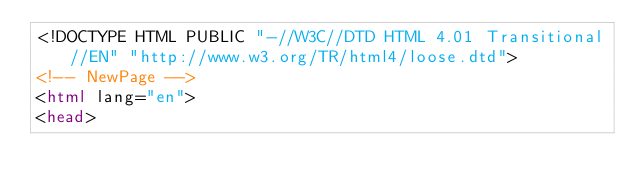<code> <loc_0><loc_0><loc_500><loc_500><_HTML_><!DOCTYPE HTML PUBLIC "-//W3C//DTD HTML 4.01 Transitional//EN" "http://www.w3.org/TR/html4/loose.dtd">
<!-- NewPage -->
<html lang="en">
<head></code> 